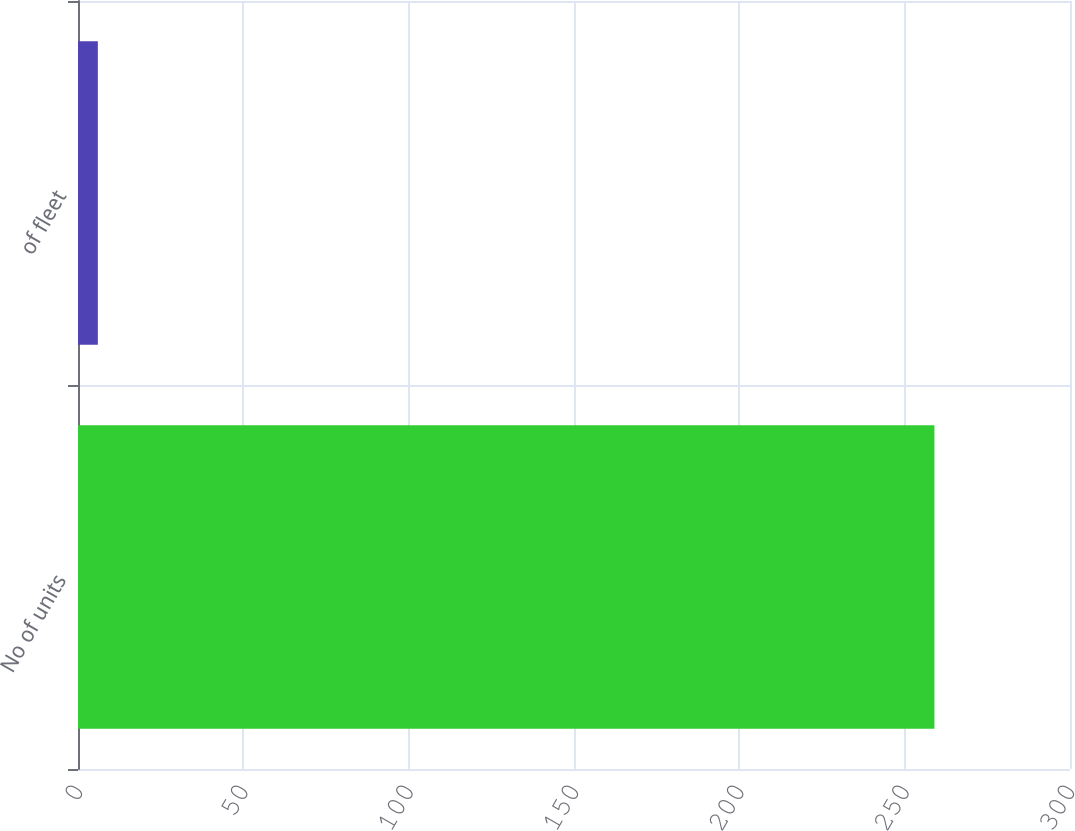Convert chart to OTSL. <chart><loc_0><loc_0><loc_500><loc_500><bar_chart><fcel>No of units<fcel>of fleet<nl><fcel>259<fcel>6<nl></chart> 